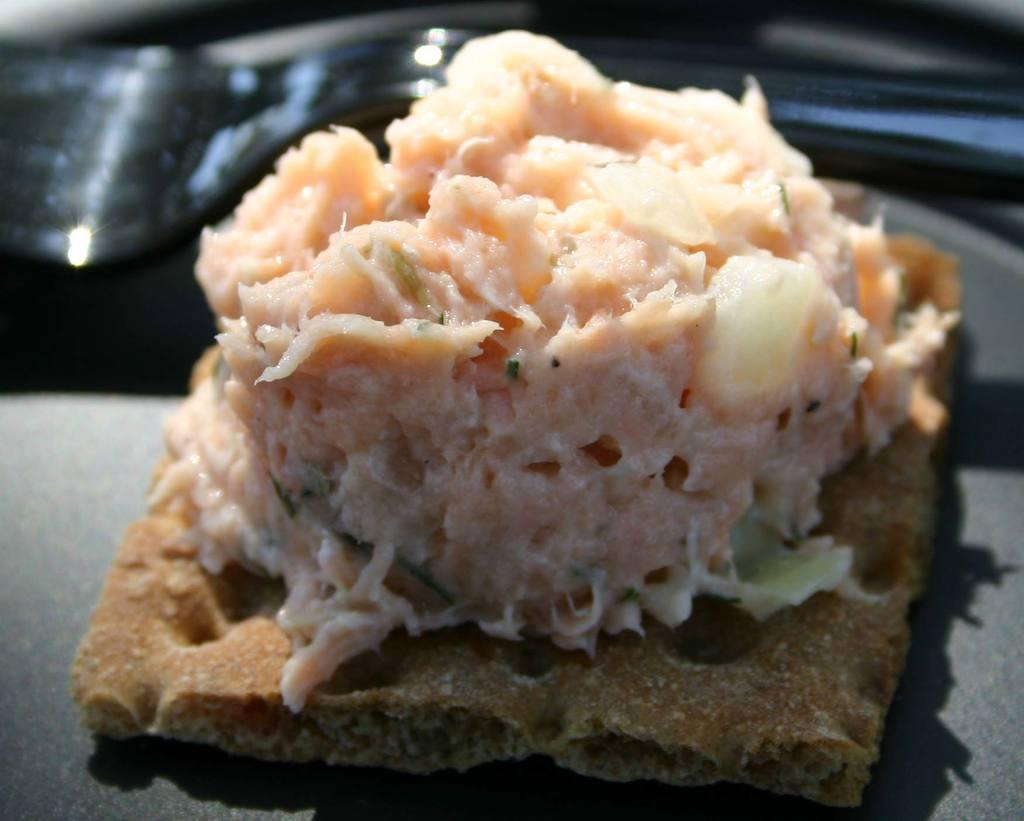What is present in the image related to eating? There is food and a fork in the image. How is the food arranged in the image? The food is in a plate. What type of sock is visible in the image? There is no sock present in the image. What is the profit margin of the food in the image? The image does not provide information about the profit margin of the food. 